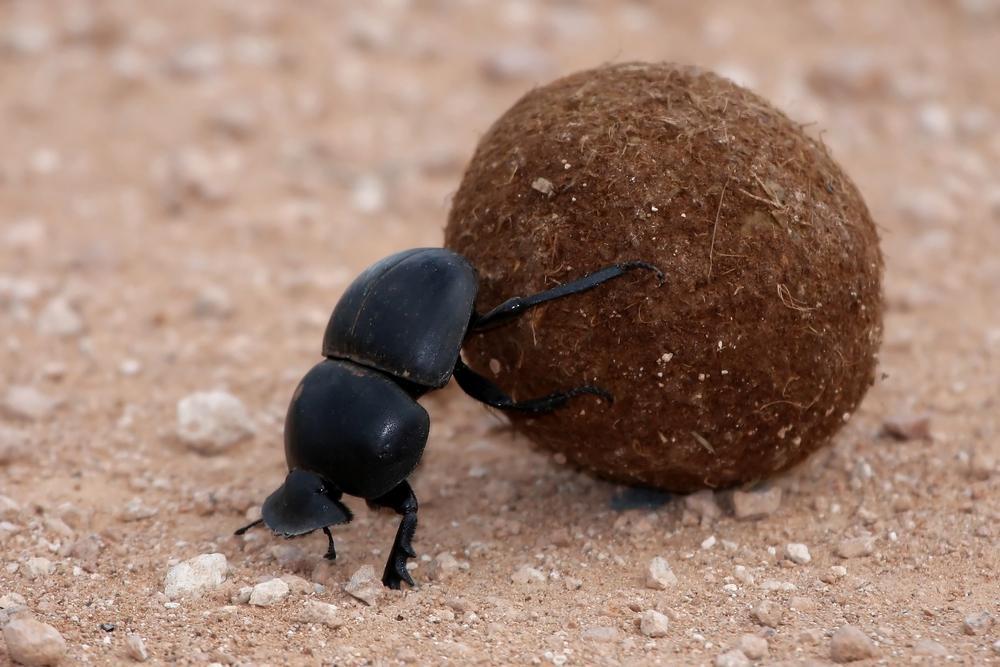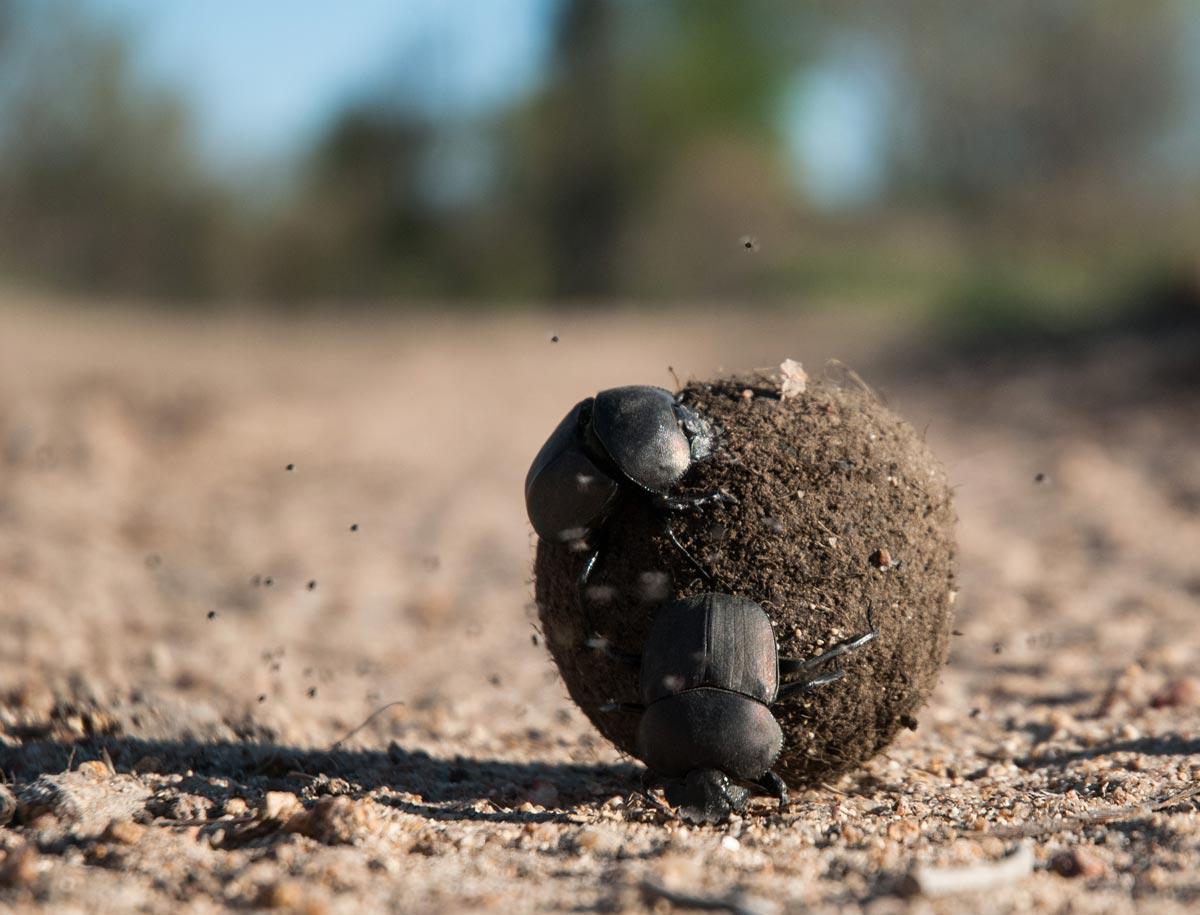The first image is the image on the left, the second image is the image on the right. Evaluate the accuracy of this statement regarding the images: "An image shows a dungball with two beetles on it, and one beetle has no part touching the ground.". Is it true? Answer yes or no. Yes. The first image is the image on the left, the second image is the image on the right. Evaluate the accuracy of this statement regarding the images: "There are two beetles on the clod of dirt in the image on the right.". Is it true? Answer yes or no. Yes. 